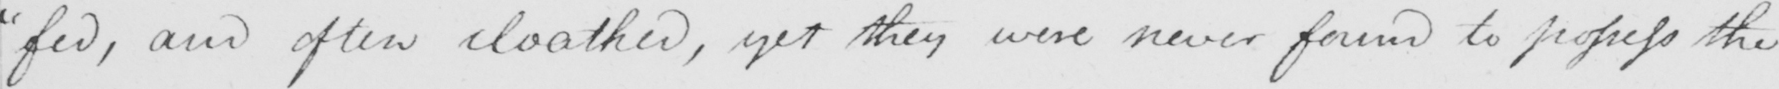Please provide the text content of this handwritten line. "fed, and often cloathed, yet they were never found to profess the 